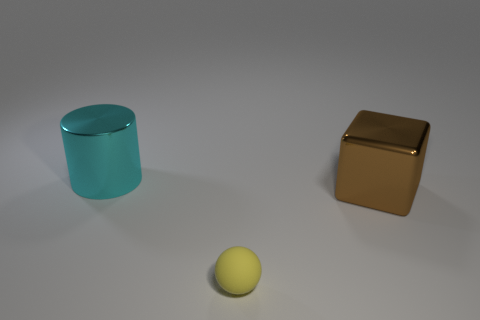Add 3 large brown metallic cubes. How many objects exist? 6 Subtract all cylinders. How many objects are left? 2 Subtract all cyan metal things. Subtract all large cyan shiny cylinders. How many objects are left? 1 Add 3 tiny rubber balls. How many tiny rubber balls are left? 4 Add 3 tiny things. How many tiny things exist? 4 Subtract 0 red spheres. How many objects are left? 3 